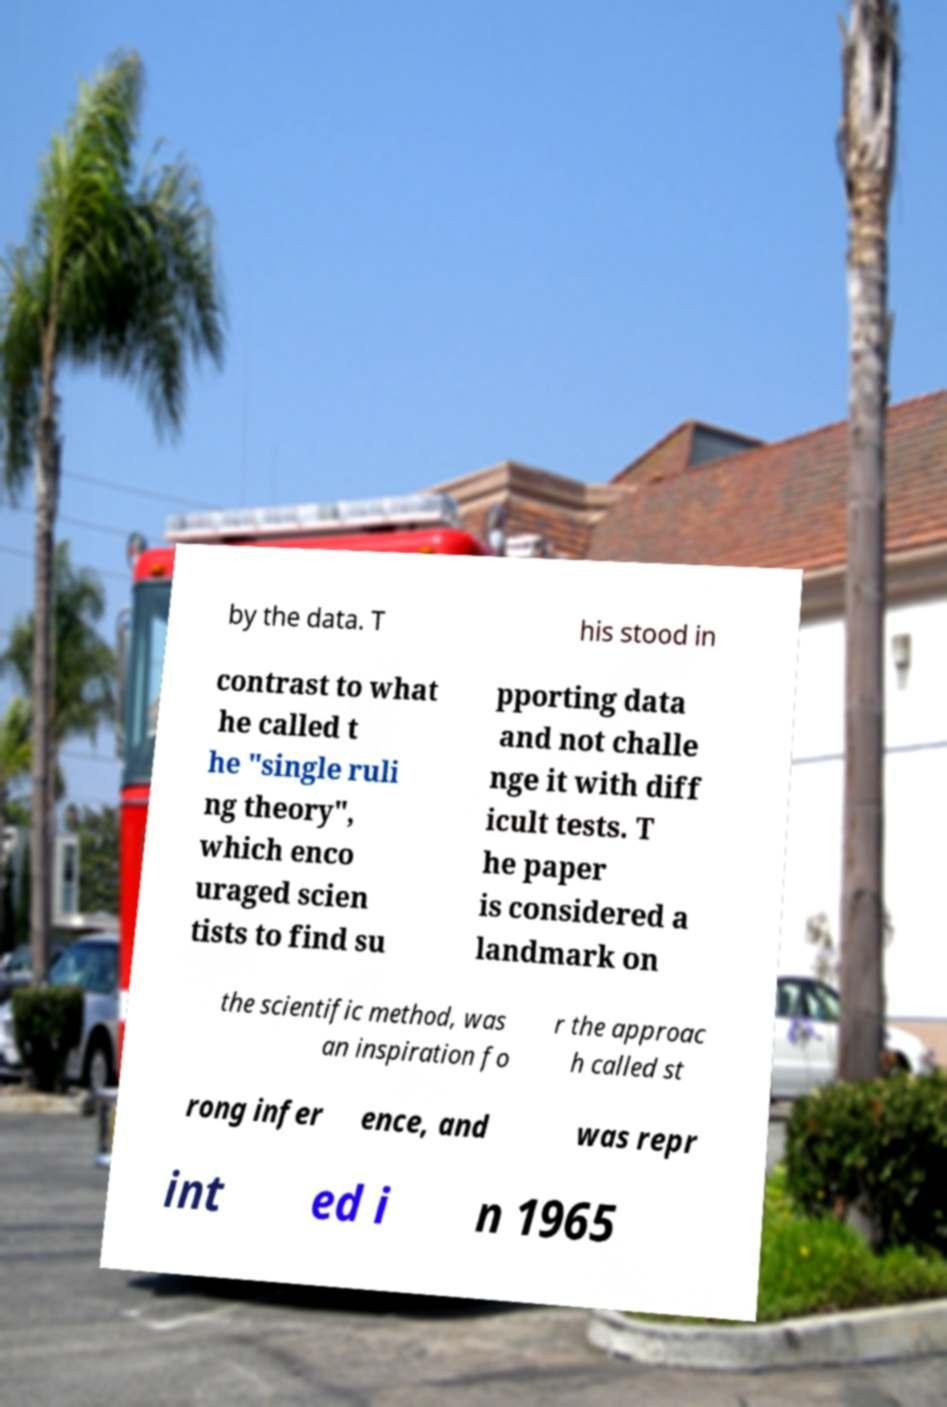Please read and relay the text visible in this image. What does it say? by the data. T his stood in contrast to what he called t he "single ruli ng theory", which enco uraged scien tists to find su pporting data and not challe nge it with diff icult tests. T he paper is considered a landmark on the scientific method, was an inspiration fo r the approac h called st rong infer ence, and was repr int ed i n 1965 